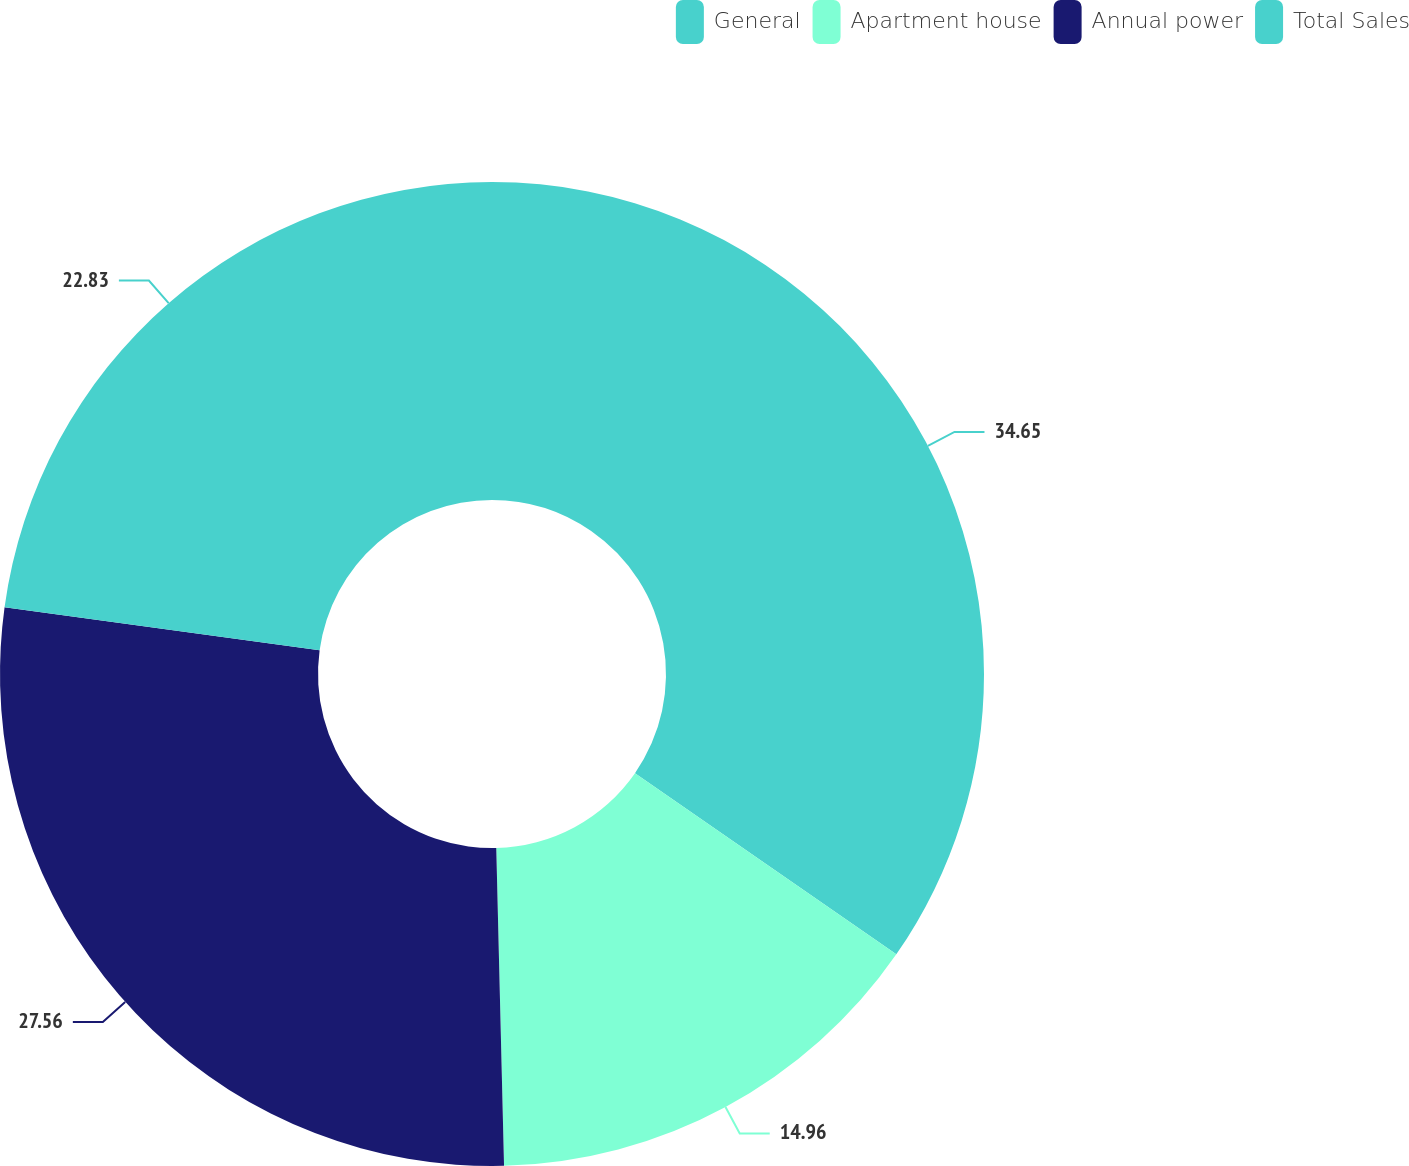Convert chart. <chart><loc_0><loc_0><loc_500><loc_500><pie_chart><fcel>General<fcel>Apartment house<fcel>Annual power<fcel>Total Sales<nl><fcel>34.65%<fcel>14.96%<fcel>27.56%<fcel>22.83%<nl></chart> 